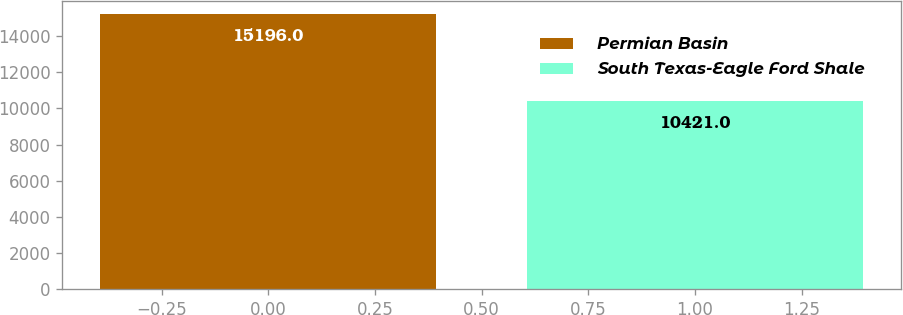<chart> <loc_0><loc_0><loc_500><loc_500><bar_chart><fcel>Permian Basin<fcel>South Texas-Eagle Ford Shale<nl><fcel>15196<fcel>10421<nl></chart> 